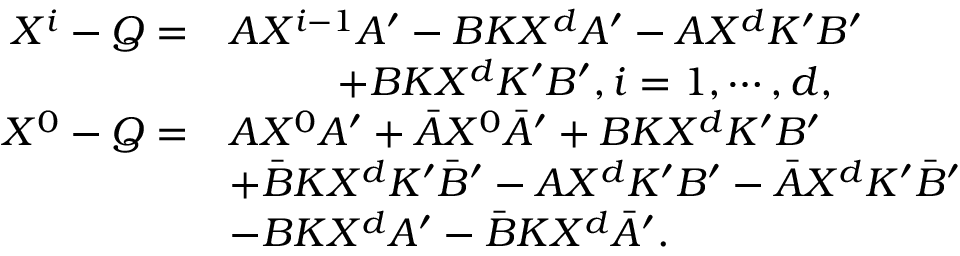Convert formula to latex. <formula><loc_0><loc_0><loc_500><loc_500>\begin{array} { r l } { X ^ { i } - Q = } & { A X ^ { i - 1 } A ^ { \prime } - B K X ^ { d } A ^ { \prime } - { A } X ^ { d } K ^ { \prime } B ^ { \prime } } \\ & { + { B } K X ^ { d } K ^ { \prime } { B } ^ { \prime } , i = 1 , \cdots , d , } \\ { X ^ { 0 } - Q = } & { A X ^ { 0 } A ^ { \prime } + \bar { A } X ^ { 0 } \bar { A } ^ { \prime } + B K X ^ { d } K ^ { \prime } B ^ { \prime } } \\ & { + \bar { B } K X ^ { d } K ^ { \prime } \bar { B } ^ { \prime } - A X ^ { d } K ^ { \prime } B ^ { \prime } - \bar { A } X ^ { d } K ^ { \prime } \bar { B } ^ { \prime } } \\ & { - B K { X } ^ { d } A ^ { \prime } - \bar { B } K { X } ^ { d } \bar { A } ^ { \prime } . } \end{array}</formula> 